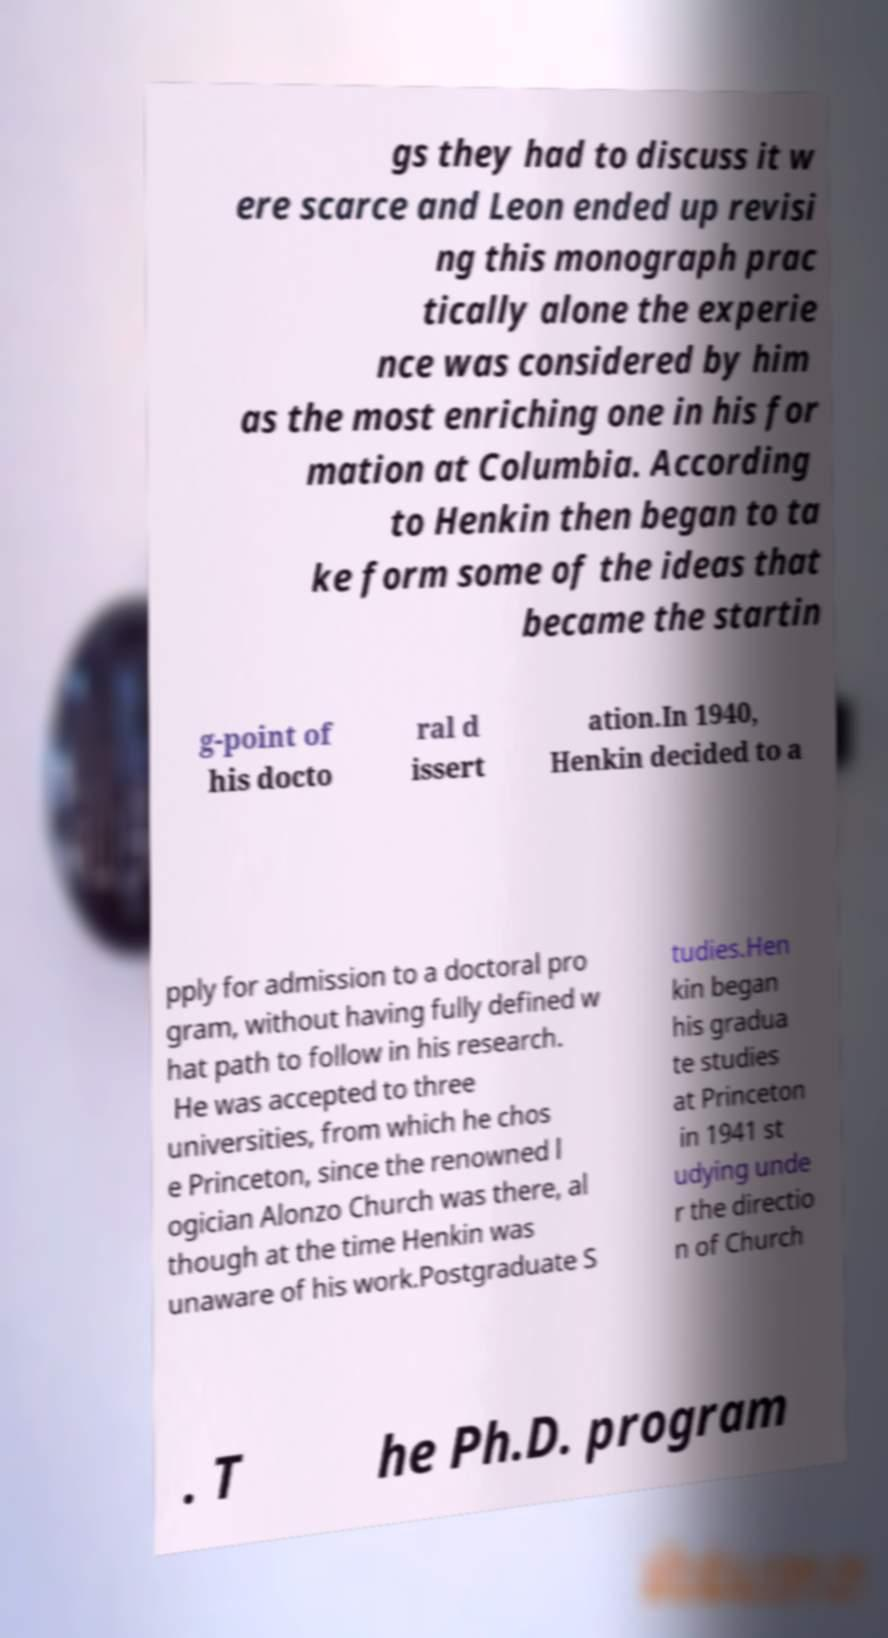Can you accurately transcribe the text from the provided image for me? gs they had to discuss it w ere scarce and Leon ended up revisi ng this monograph prac tically alone the experie nce was considered by him as the most enriching one in his for mation at Columbia. According to Henkin then began to ta ke form some of the ideas that became the startin g-point of his docto ral d issert ation.In 1940, Henkin decided to a pply for admission to a doctoral pro gram, without having fully defined w hat path to follow in his research. He was accepted to three universities, from which he chos e Princeton, since the renowned l ogician Alonzo Church was there, al though at the time Henkin was unaware of his work.Postgraduate S tudies.Hen kin began his gradua te studies at Princeton in 1941 st udying unde r the directio n of Church . T he Ph.D. program 